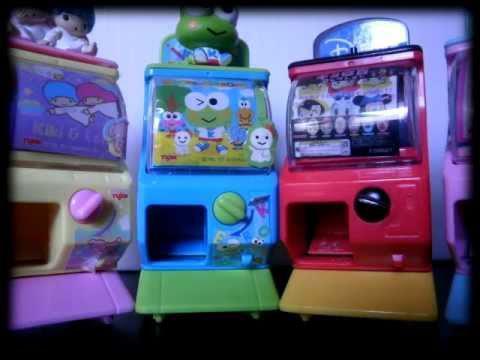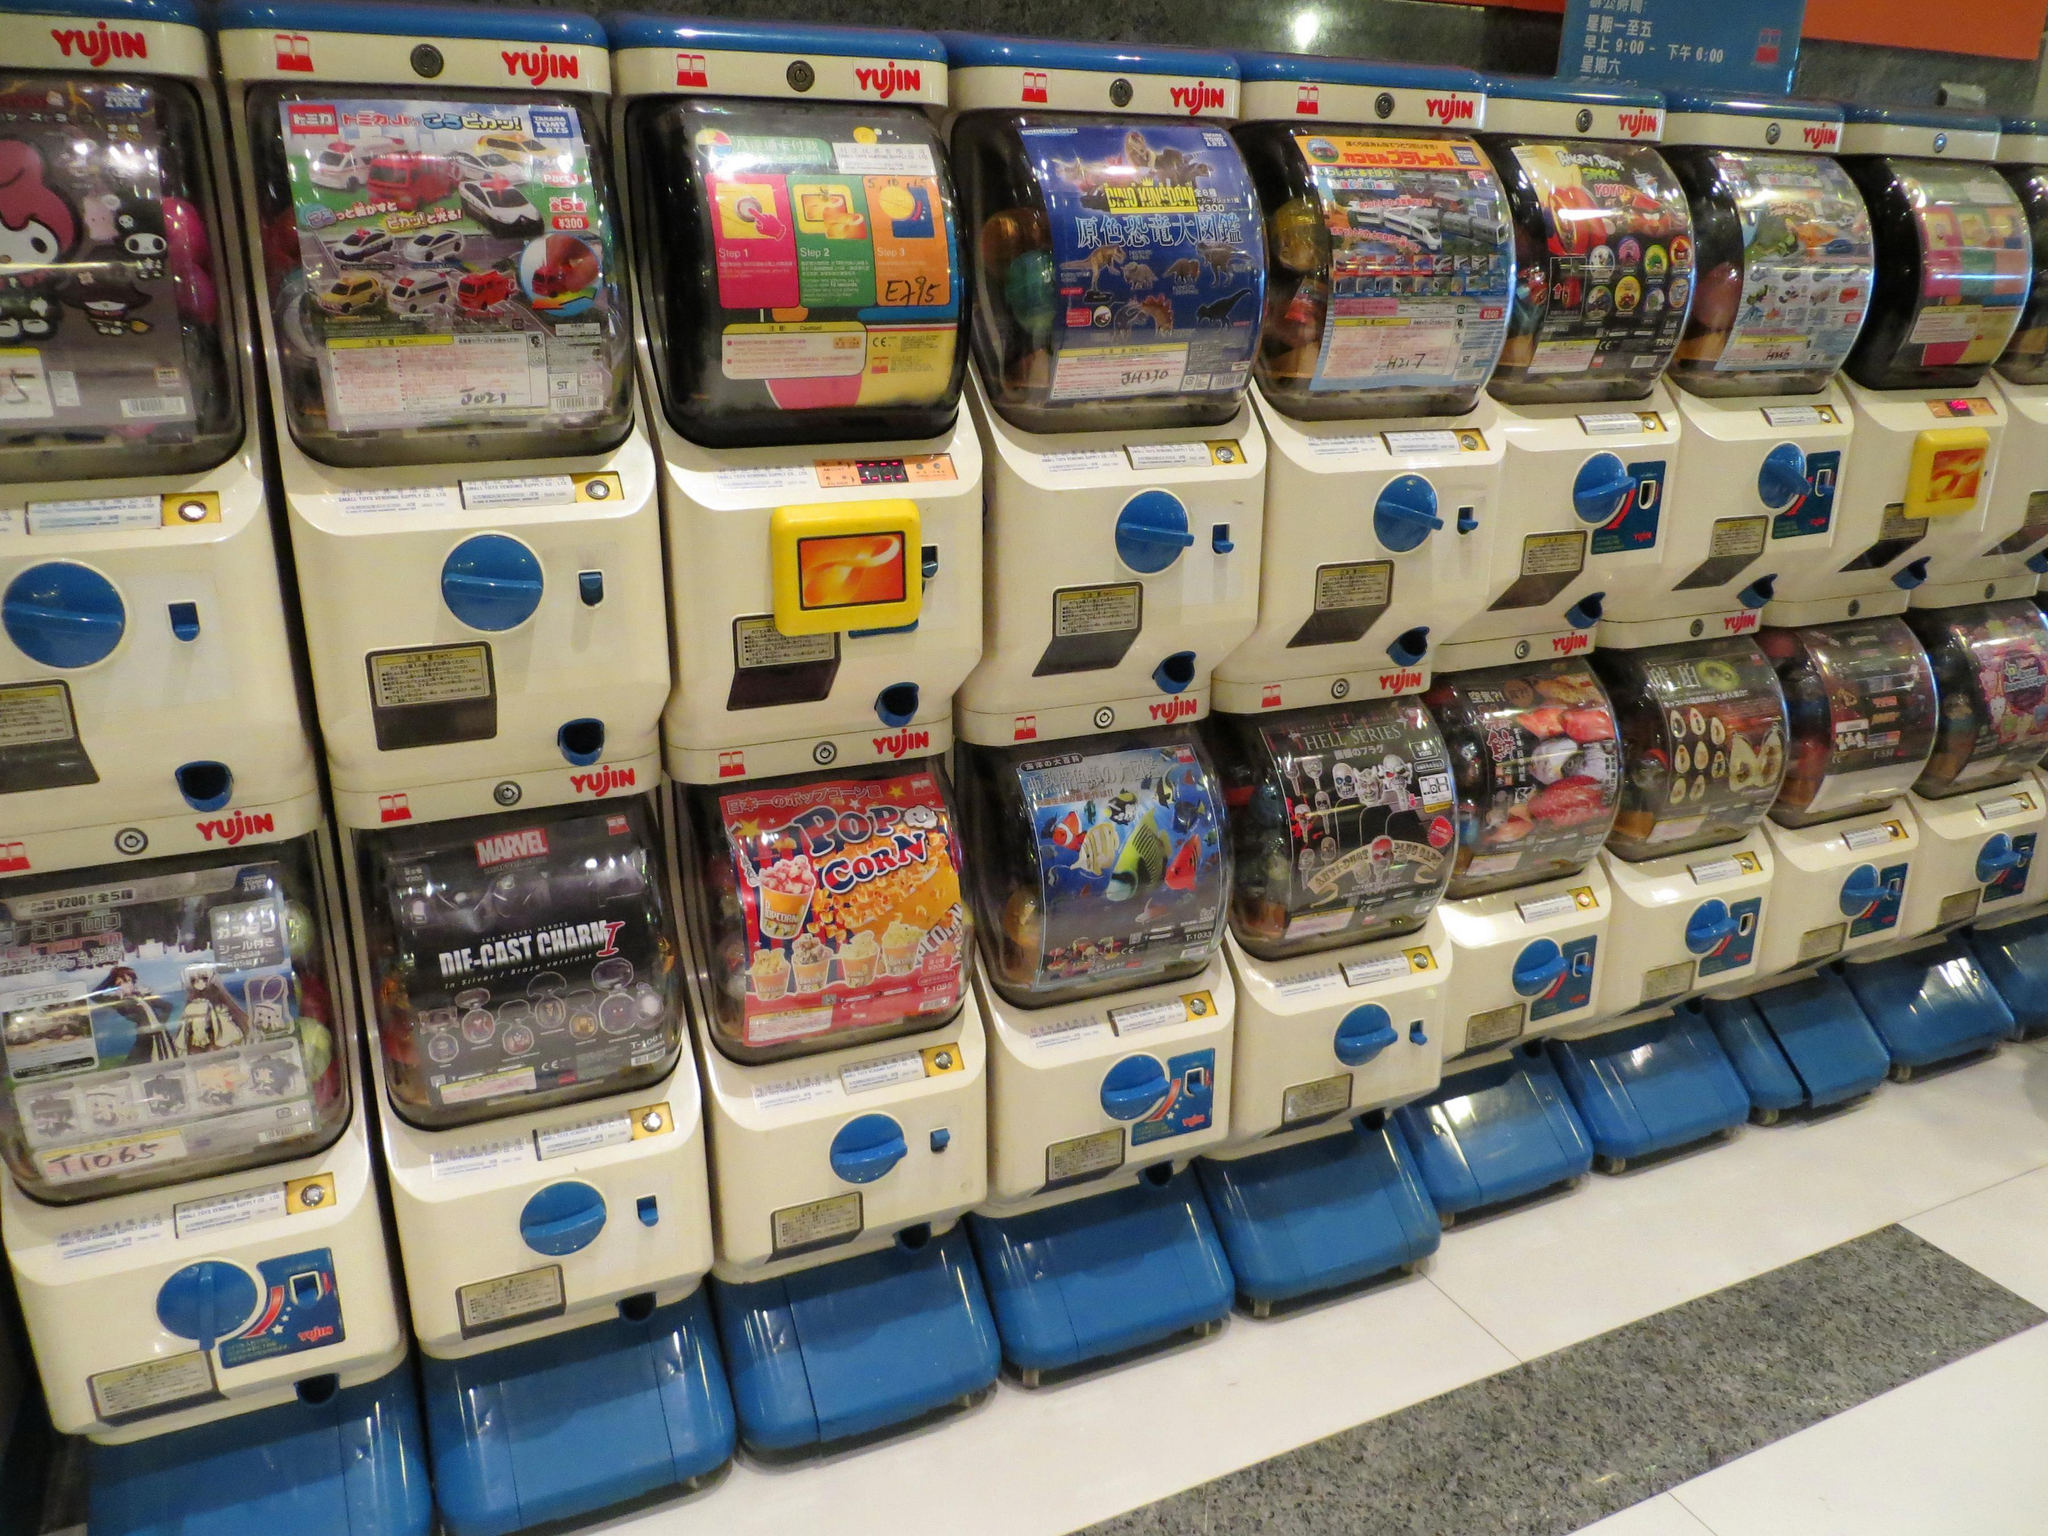The first image is the image on the left, the second image is the image on the right. Considering the images on both sides, is "There are toy vending machines in both images." valid? Answer yes or no. Yes. The first image is the image on the left, the second image is the image on the right. For the images displayed, is the sentence "An image shows two straight stacked rows of vending machines, at least 8 across." factually correct? Answer yes or no. Yes. 